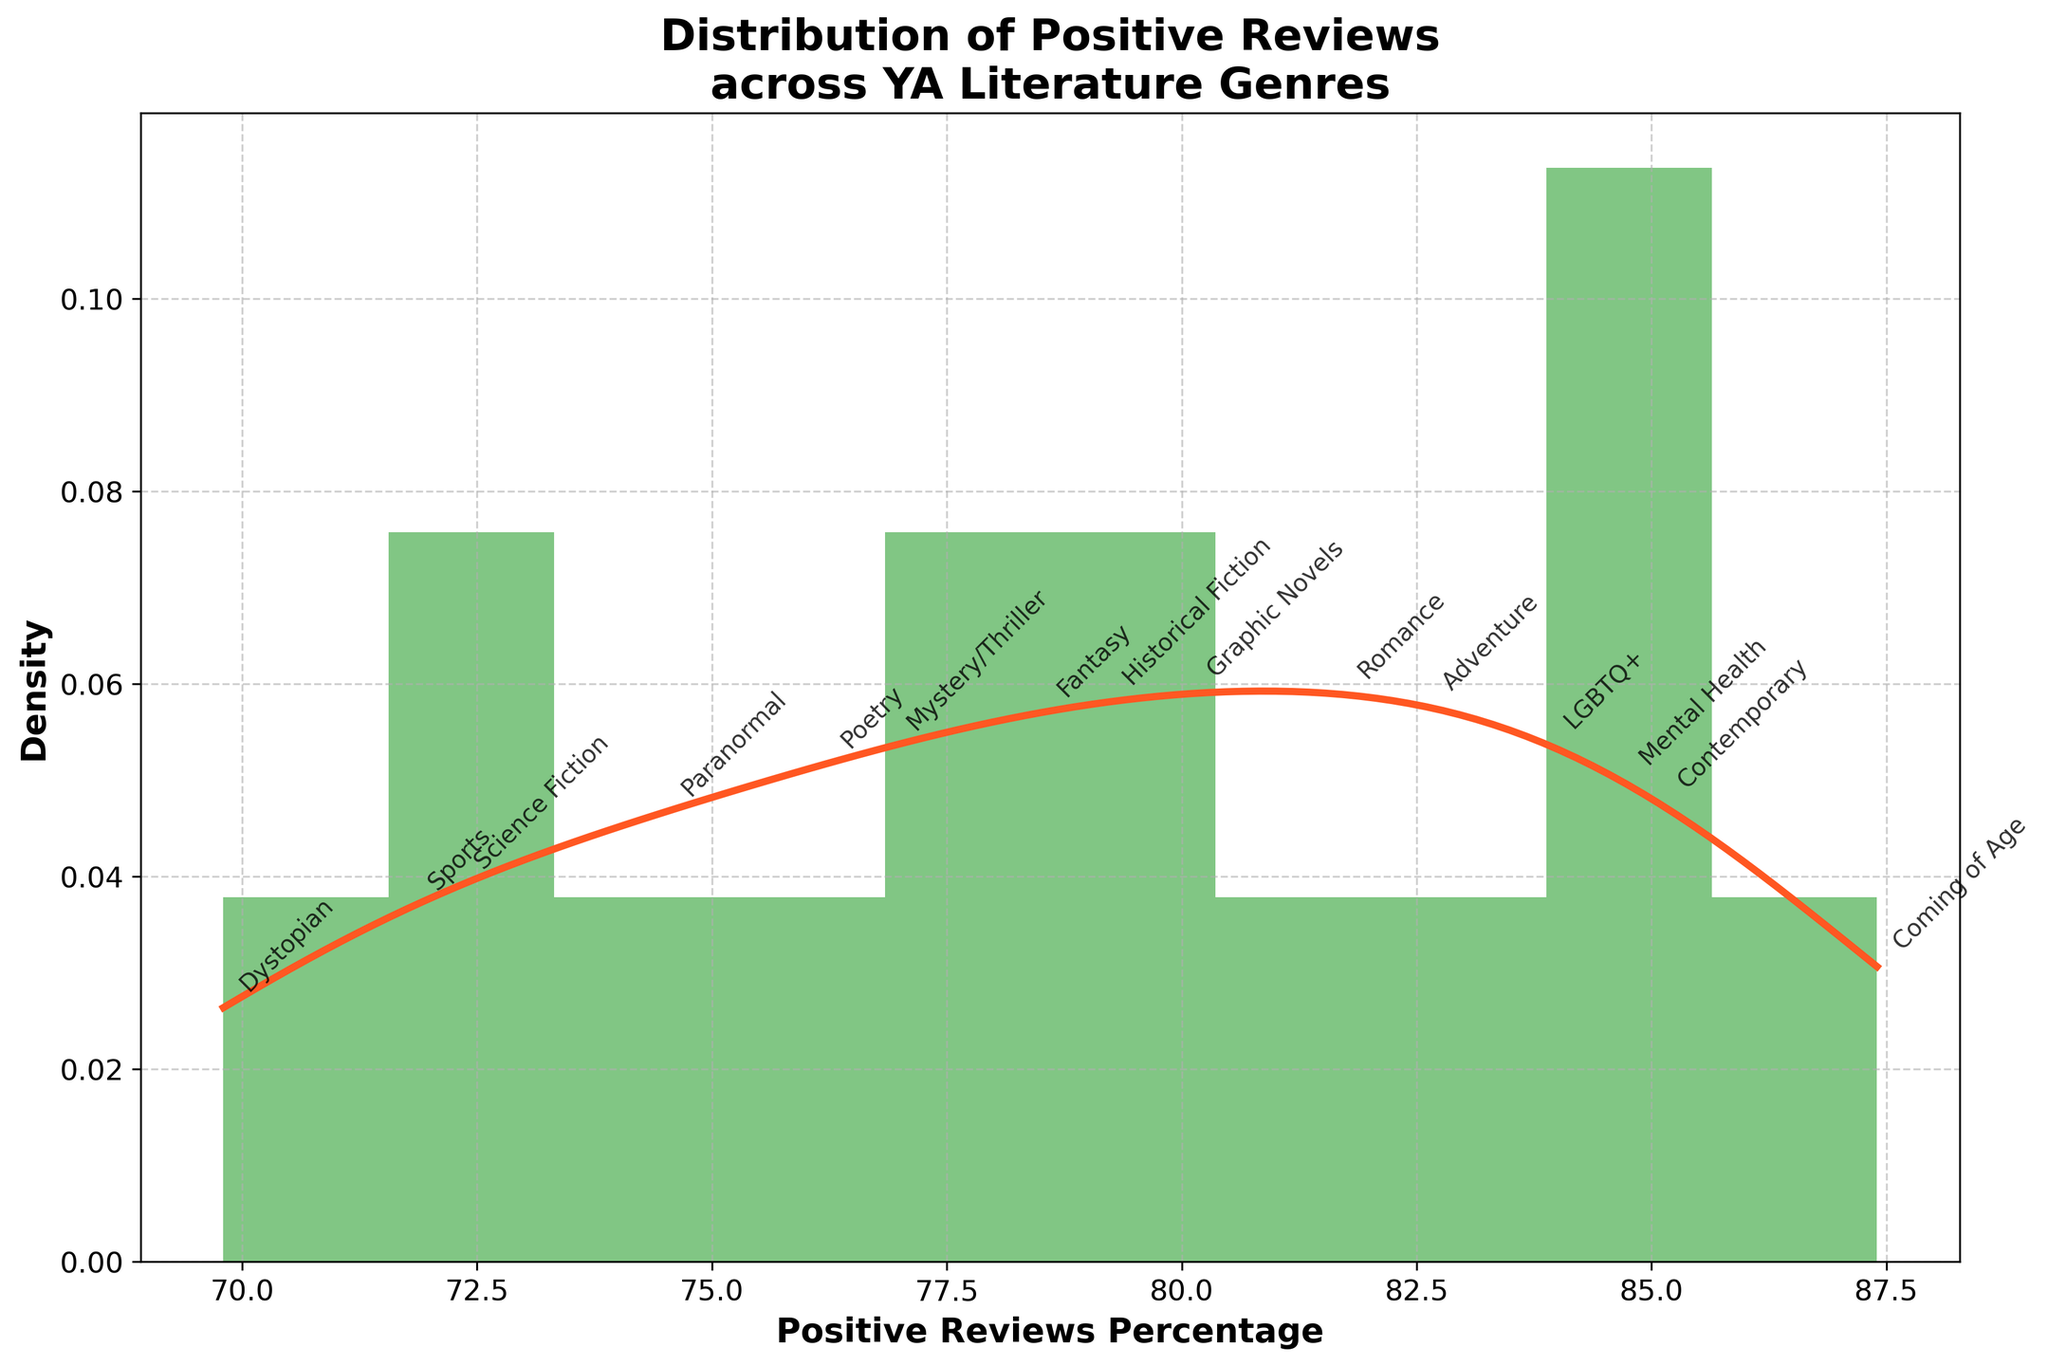Which genre has the highest percentage of positive reviews? The genre with the highest positive review percentage can be identified directly on the plot, where the annotations are spread across the KDE line. "Coming of Age" has the highest peak.
Answer: Coming of Age What is the title of the figure? The title of the figure is displayed at the top of the plot.
Answer: Distribution of Positive Reviews across YA Literature Genres How many bins are used in the histogram? The bins in the histogram are shown as separate bars along the x-axis. Count the number of these bars.
Answer: 10 Which genre has the lowest percentage of positive reviews? To find the lowest positive review percentage, look for the annotation with the smallest value along the KDE curve. "Dystopian" is the lowest.
Answer: Dystopian What is the range of positive review percentages depicted in the figure? The range can be determined by finding the minimum and maximum percentages annotated on the x-axis. They span from the lowest to the highest annotated value.
Answer: 69.8 to 87.4 How does the density curve (KDE) help in understanding the data distribution? The KDE smooths out the histogram bars to give a clearer idea of where data points are concentrated, showing the probability density of different percentages of positive reviews. It helps visualize trends and peaks in the data.
Answer: Highlights data concentration and trends Which genres have a higher percentage of positive reviews than Romance? By comparing the annotated percentages for each genre with Romance (81.7), we can identify genres with higher percentages.
Answer: Adventure, Coming of Age, LGBTQ+, Mental Health, Contemporary What is the average positive review percentage across all genres? Summing all the given percentages and dividing by the number of genres (15) gives the average. Calculating: (78.5 + 72.3 + 85.1 + 81.7 + 76.9 + 69.8 + 79.2 + 82.6 + 87.4 + 74.5 + 83.9 + 80.1 + 76.2 + 84.7 + 71.8) / 15 = 79.6%
Answer: 79.6% How does the density curve compare visually with the histogram bars? The density curve provides a smooth representation of data frequency which can reveal trends not immediately visible from the histogram's discrete bars. Look at how the KDE line smooths over the peaks and troughs.
Answer: Smooths over discrete bars, reveals trends Are there any genres clustered around a specific percentage range? Observing the KDE line and the heights of the histogram bars, genres clustered around a certain percentage can be identified. Many genres cluster around the 80% range, shown by the higher density in that area.
Answer: Around 80% 